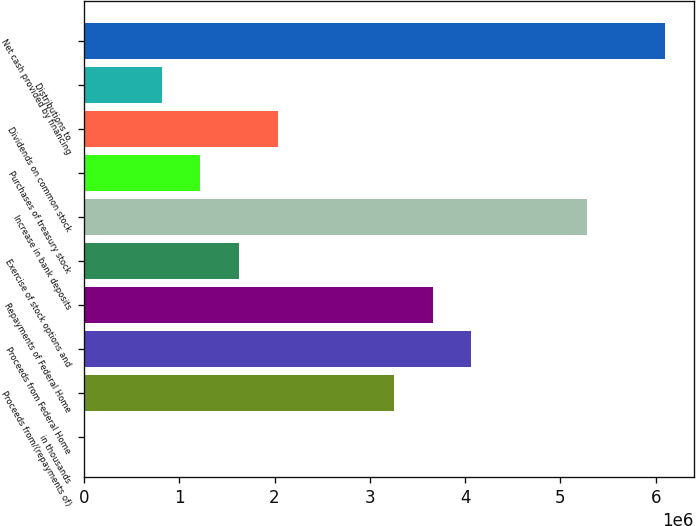Convert chart. <chart><loc_0><loc_0><loc_500><loc_500><bar_chart><fcel>in thousands<fcel>Proceeds from/(repayments of)<fcel>Proceeds from Federal Home<fcel>Repayments of Federal Home<fcel>Exercise of stock options and<fcel>Increase in bank deposits<fcel>Purchases of treasury stock<fcel>Dividends on common stock<fcel>Distributions to<fcel>Net cash provided by financing<nl><fcel>2017<fcel>3.25205e+06<fcel>4.06456e+06<fcel>3.65831e+06<fcel>1.62704e+06<fcel>5.28333e+06<fcel>1.22078e+06<fcel>2.03329e+06<fcel>814526<fcel>6.09584e+06<nl></chart> 